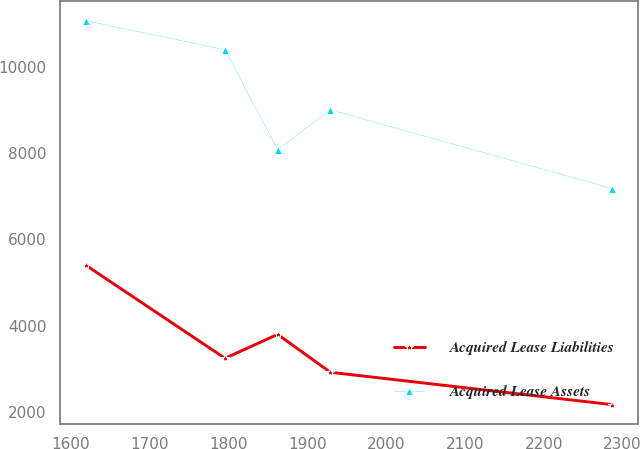Convert chart to OTSL. <chart><loc_0><loc_0><loc_500><loc_500><line_chart><ecel><fcel>Acquired Lease Liabilities<fcel>Acquired Lease Assets<nl><fcel>1619.07<fcel>5402.35<fcel>11071.9<nl><fcel>1795.67<fcel>3244.66<fcel>10397.3<nl><fcel>1862.43<fcel>3798.26<fcel>8081.63<nl><fcel>1929.19<fcel>2921.47<fcel>9006.94<nl><fcel>2286.67<fcel>2170.4<fcel>7180.14<nl></chart> 